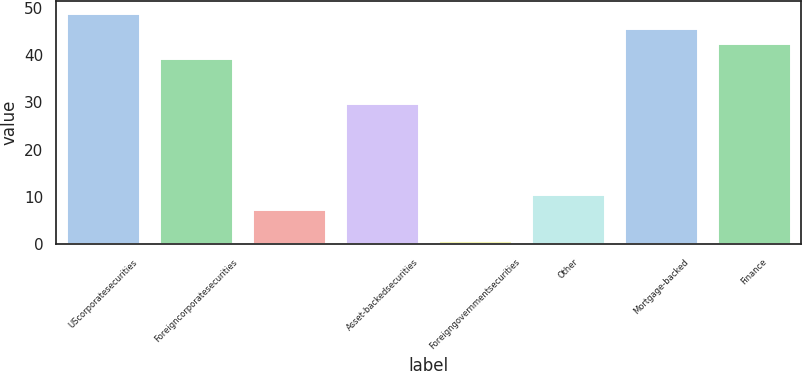Convert chart to OTSL. <chart><loc_0><loc_0><loc_500><loc_500><bar_chart><fcel>UScorporatesecurities<fcel>Foreigncorporatesecurities<fcel>Unnamed: 2<fcel>Asset-backedsecurities<fcel>Foreigngovernmentsecurities<fcel>Other<fcel>Mortgage-backed<fcel>Finance<nl><fcel>49<fcel>39.4<fcel>7.4<fcel>29.8<fcel>1<fcel>10.6<fcel>45.8<fcel>42.6<nl></chart> 